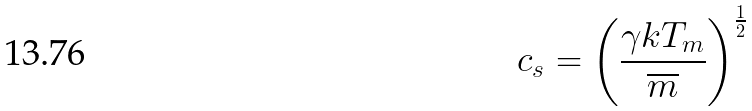Convert formula to latex. <formula><loc_0><loc_0><loc_500><loc_500>c _ { s } = \left ( \frac { \gamma k T _ { m } } { \overline { m } } \right ) ^ { \frac { 1 } { 2 } }</formula> 